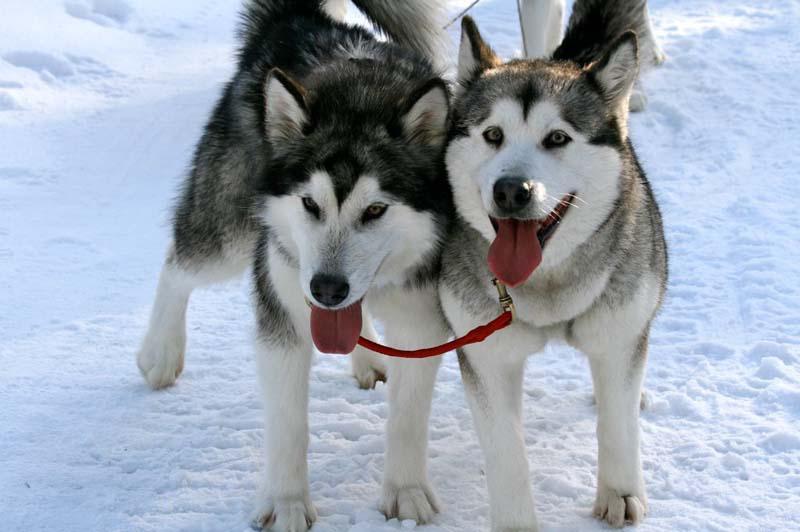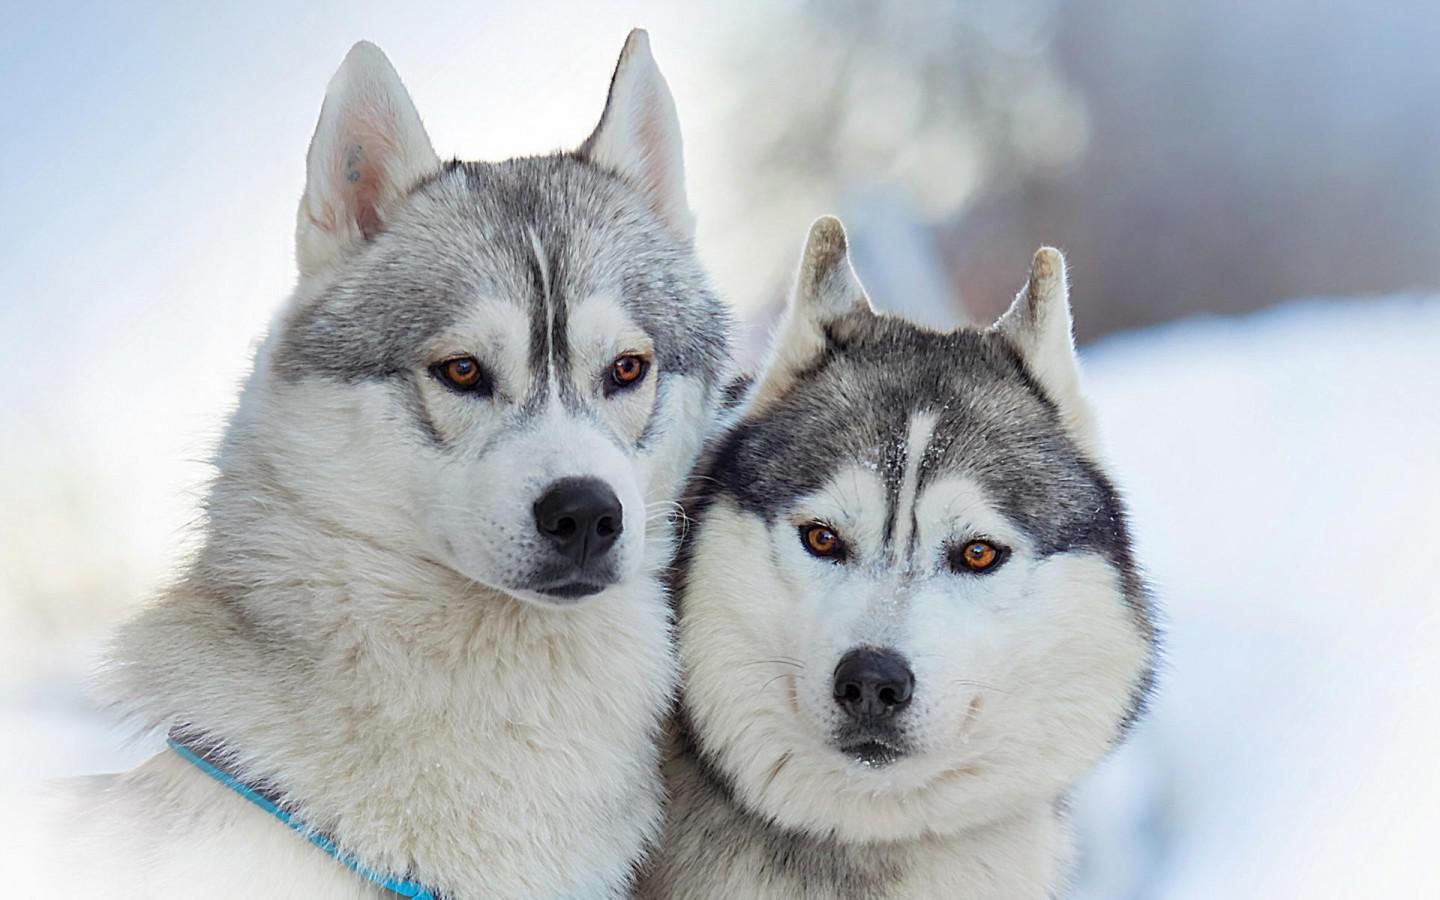The first image is the image on the left, the second image is the image on the right. Given the left and right images, does the statement "The left image contains two dogs surrounded by snow." hold true? Answer yes or no. Yes. The first image is the image on the left, the second image is the image on the right. Given the left and right images, does the statement "The left and right images contain pairs of husky dogs in the snow, and at least some dogs are 'hitched' with ropes." hold true? Answer yes or no. Yes. 